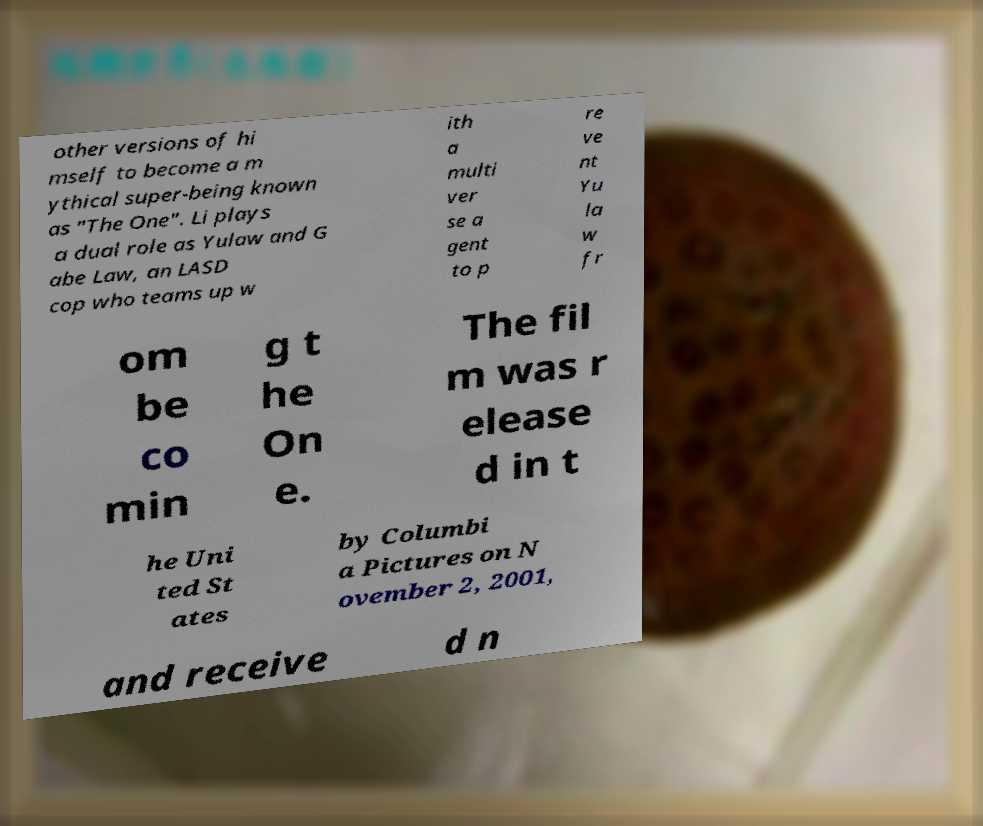Please identify and transcribe the text found in this image. other versions of hi mself to become a m ythical super-being known as "The One". Li plays a dual role as Yulaw and G abe Law, an LASD cop who teams up w ith a multi ver se a gent to p re ve nt Yu la w fr om be co min g t he On e. The fil m was r elease d in t he Uni ted St ates by Columbi a Pictures on N ovember 2, 2001, and receive d n 